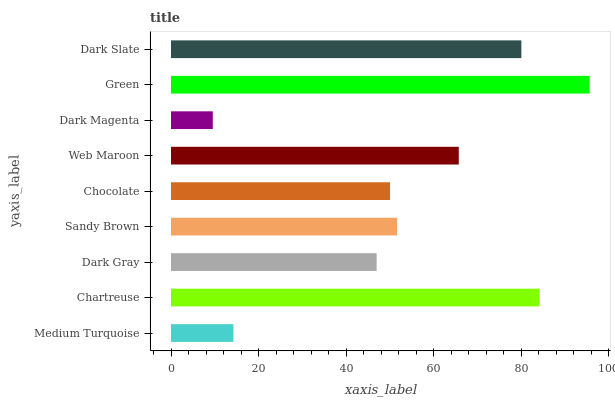Is Dark Magenta the minimum?
Answer yes or no. Yes. Is Green the maximum?
Answer yes or no. Yes. Is Chartreuse the minimum?
Answer yes or no. No. Is Chartreuse the maximum?
Answer yes or no. No. Is Chartreuse greater than Medium Turquoise?
Answer yes or no. Yes. Is Medium Turquoise less than Chartreuse?
Answer yes or no. Yes. Is Medium Turquoise greater than Chartreuse?
Answer yes or no. No. Is Chartreuse less than Medium Turquoise?
Answer yes or no. No. Is Sandy Brown the high median?
Answer yes or no. Yes. Is Sandy Brown the low median?
Answer yes or no. Yes. Is Dark Slate the high median?
Answer yes or no. No. Is Dark Magenta the low median?
Answer yes or no. No. 